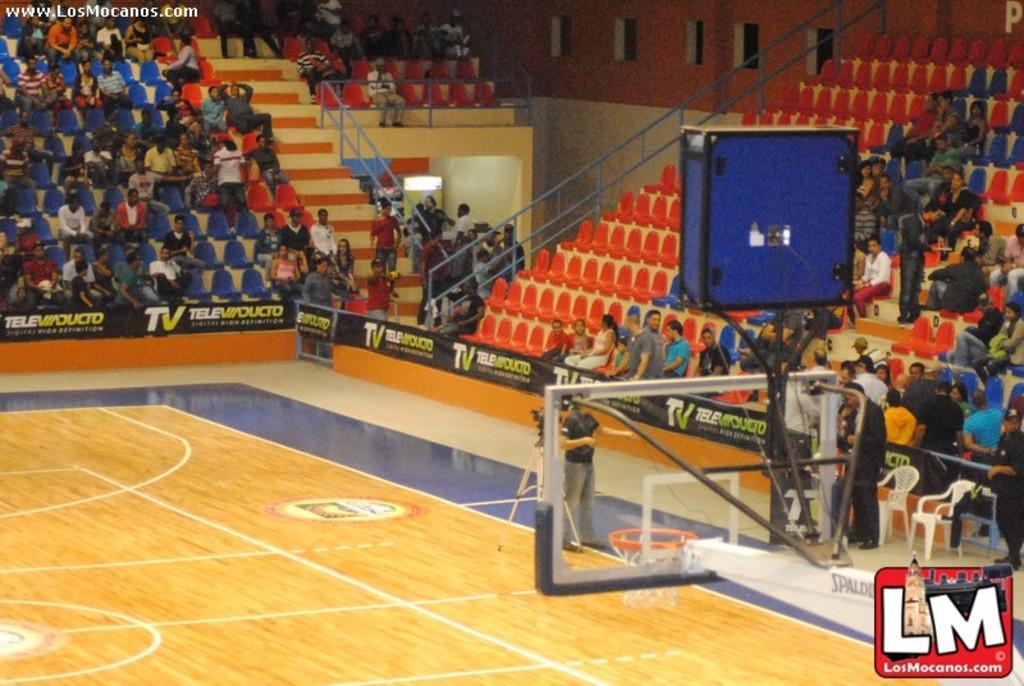Provide a one-sentence caption for the provided image. Footage from the basketball court is brought to you by www.LosMocanos.com. 